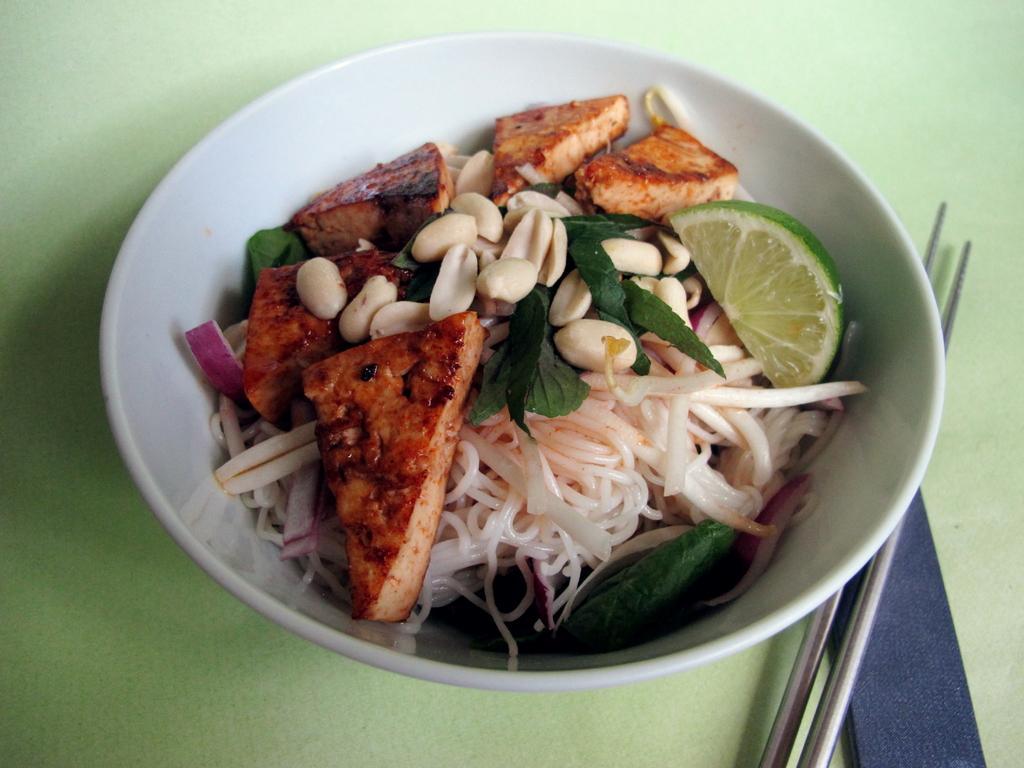Describe this image in one or two sentences. Here I can see a table on which a white color bowl and two chopsticks are placed. In the bowl I can see some food items like bread slices, noodles, lemon, peanuts and leaves. 